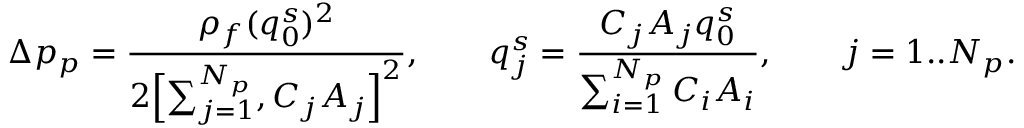<formula> <loc_0><loc_0><loc_500><loc_500>\Delta p _ { p } = \frac { \rho _ { f } ( q _ { 0 } ^ { s } ) ^ { 2 } } { 2 \left [ \sum _ { j = 1 } ^ { N _ { p } } , C _ { j } A _ { j } \right ] ^ { 2 } } , \quad q _ { j } ^ { s } = \frac { C _ { j } A _ { j } q _ { 0 } ^ { s } } { \sum _ { i = 1 } ^ { N _ { p } } C _ { i } A _ { i } } , \quad j = 1 . . N _ { p } .</formula> 